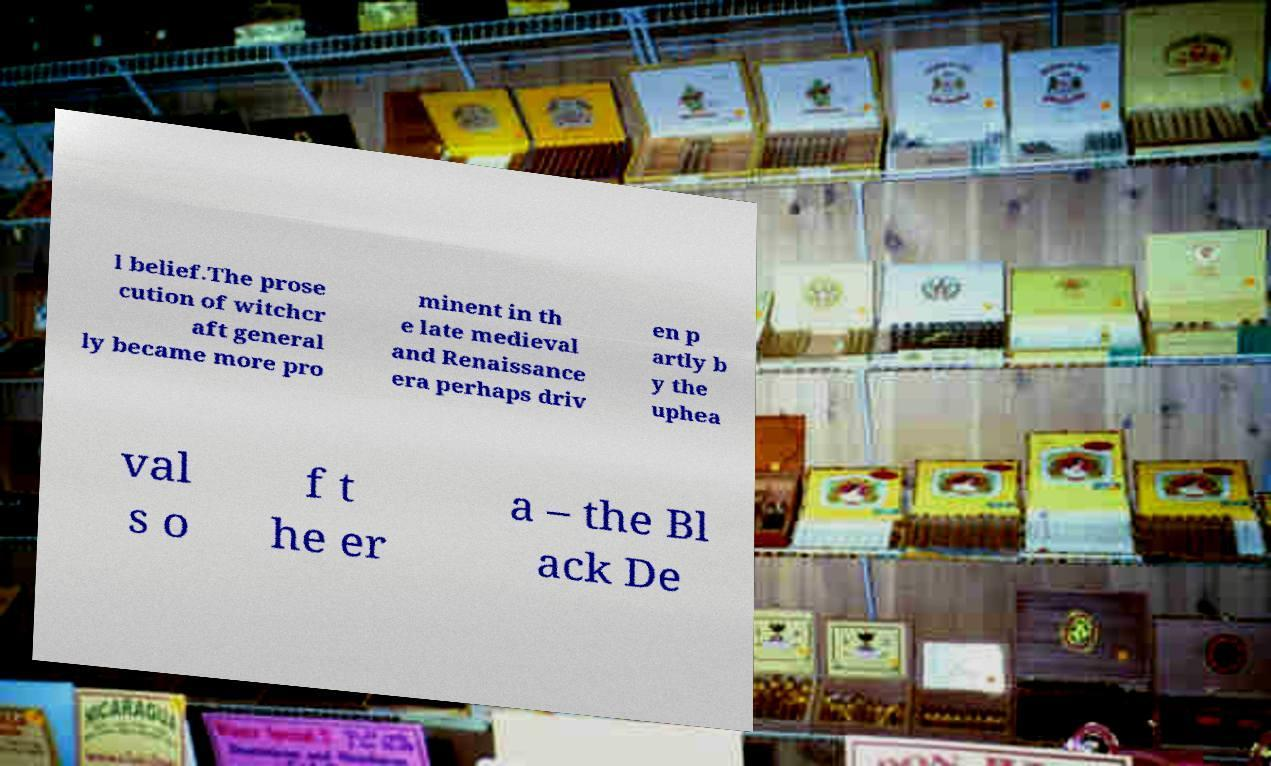Please read and relay the text visible in this image. What does it say? l belief.The prose cution of witchcr aft general ly became more pro minent in th e late medieval and Renaissance era perhaps driv en p artly b y the uphea val s o f t he er a – the Bl ack De 